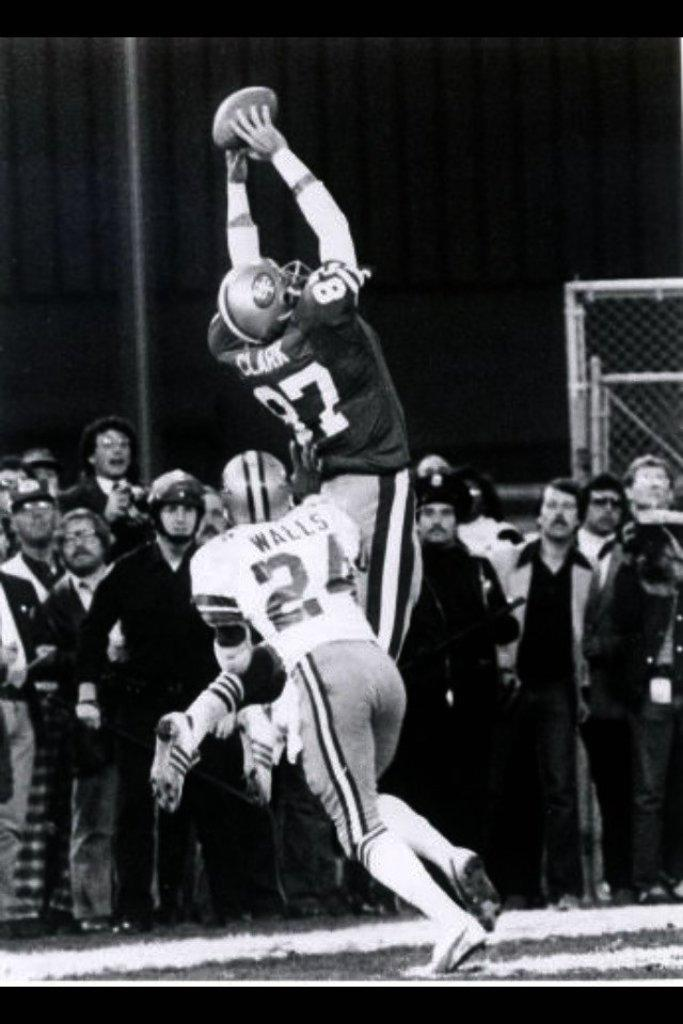What are the two persons in the foreground of the image doing? The two persons are playing on the ground. What can be seen in the background of the image? There are other persons watching them in the background, and there is a net in the background as well. What is the color of the surface in the background? The surface in the background is gray colored. How many strangers are present in the image? The term "stranger" is not mentioned in the facts provided, so it is not possible to determine the number of strangers in the image. 